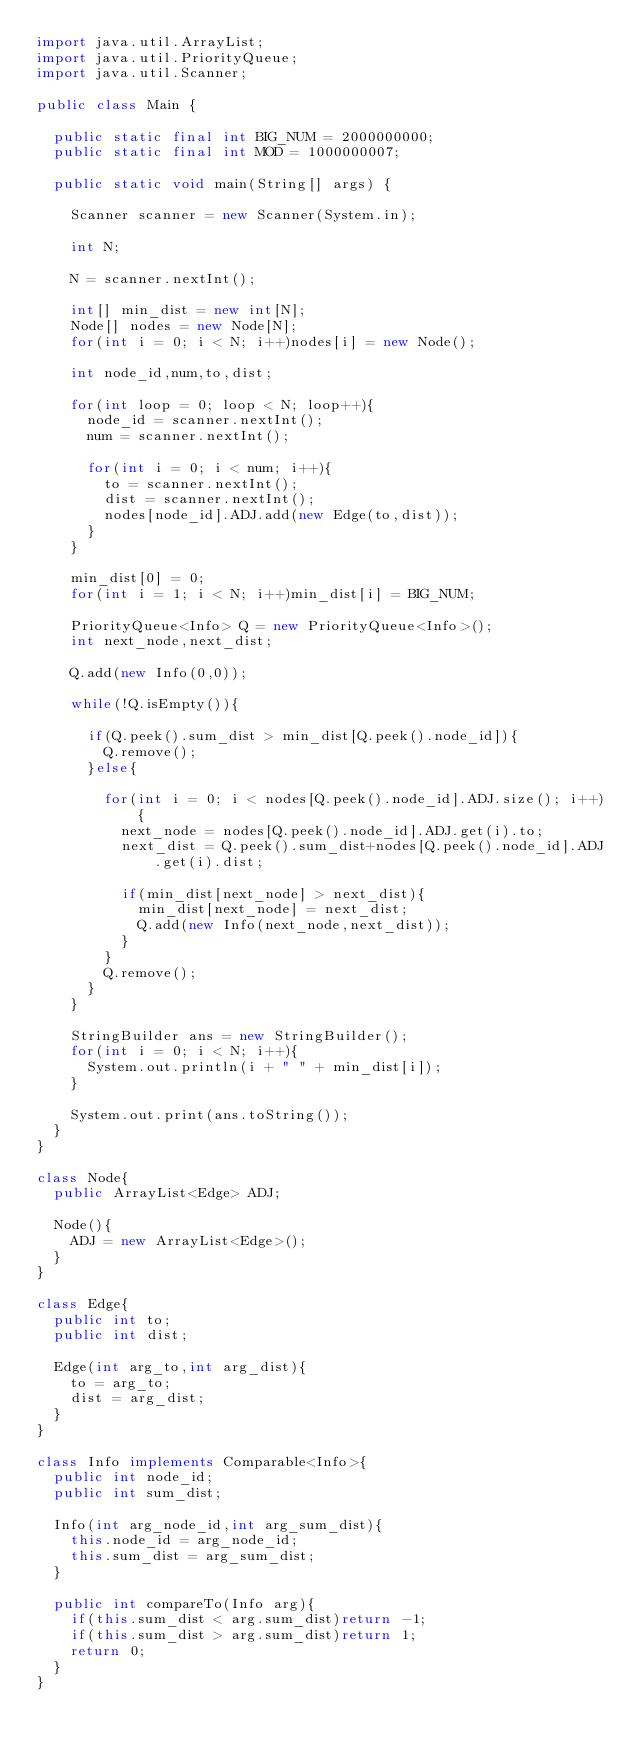<code> <loc_0><loc_0><loc_500><loc_500><_Java_>import java.util.ArrayList;
import java.util.PriorityQueue;
import java.util.Scanner;

public class Main {

	public static final int BIG_NUM = 2000000000;
	public static final int MOD = 1000000007;

	public static void main(String[] args) {

		Scanner scanner = new Scanner(System.in);

		int N;

		N = scanner.nextInt();

		int[] min_dist = new int[N];
		Node[] nodes = new Node[N];
		for(int i = 0; i < N; i++)nodes[i] = new Node();

		int node_id,num,to,dist;

		for(int loop = 0; loop < N; loop++){
			node_id = scanner.nextInt();
			num = scanner.nextInt();

			for(int i = 0; i < num; i++){
				to = scanner.nextInt();
				dist = scanner.nextInt();
				nodes[node_id].ADJ.add(new Edge(to,dist));
			}
		}

		min_dist[0] = 0;
		for(int i = 1; i < N; i++)min_dist[i] = BIG_NUM;

		PriorityQueue<Info> Q = new PriorityQueue<Info>();
		int next_node,next_dist;

		Q.add(new Info(0,0));

		while(!Q.isEmpty()){

			if(Q.peek().sum_dist > min_dist[Q.peek().node_id]){
				Q.remove();
			}else{

				for(int i = 0; i < nodes[Q.peek().node_id].ADJ.size(); i++){
					next_node = nodes[Q.peek().node_id].ADJ.get(i).to;
					next_dist = Q.peek().sum_dist+nodes[Q.peek().node_id].ADJ.get(i).dist;

					if(min_dist[next_node] > next_dist){
						min_dist[next_node] = next_dist;
						Q.add(new Info(next_node,next_dist));
					}
				}
				Q.remove();
			}
		}

		StringBuilder ans = new StringBuilder();
		for(int i = 0; i < N; i++){
			System.out.println(i + " " + min_dist[i]);
		}

		System.out.print(ans.toString());
	}
}

class Node{
	public ArrayList<Edge> ADJ;

	Node(){
		ADJ = new ArrayList<Edge>();
	}
}

class Edge{
	public int to;
	public int dist;

	Edge(int arg_to,int arg_dist){
		to = arg_to;
		dist = arg_dist;
	}
}

class Info implements Comparable<Info>{
	public int node_id;
	public int sum_dist;

	Info(int arg_node_id,int arg_sum_dist){
		this.node_id = arg_node_id;
		this.sum_dist = arg_sum_dist;
	}

	public int compareTo(Info arg){
		if(this.sum_dist < arg.sum_dist)return -1;
		if(this.sum_dist > arg.sum_dist)return 1;
		return 0;
	}
}


</code> 